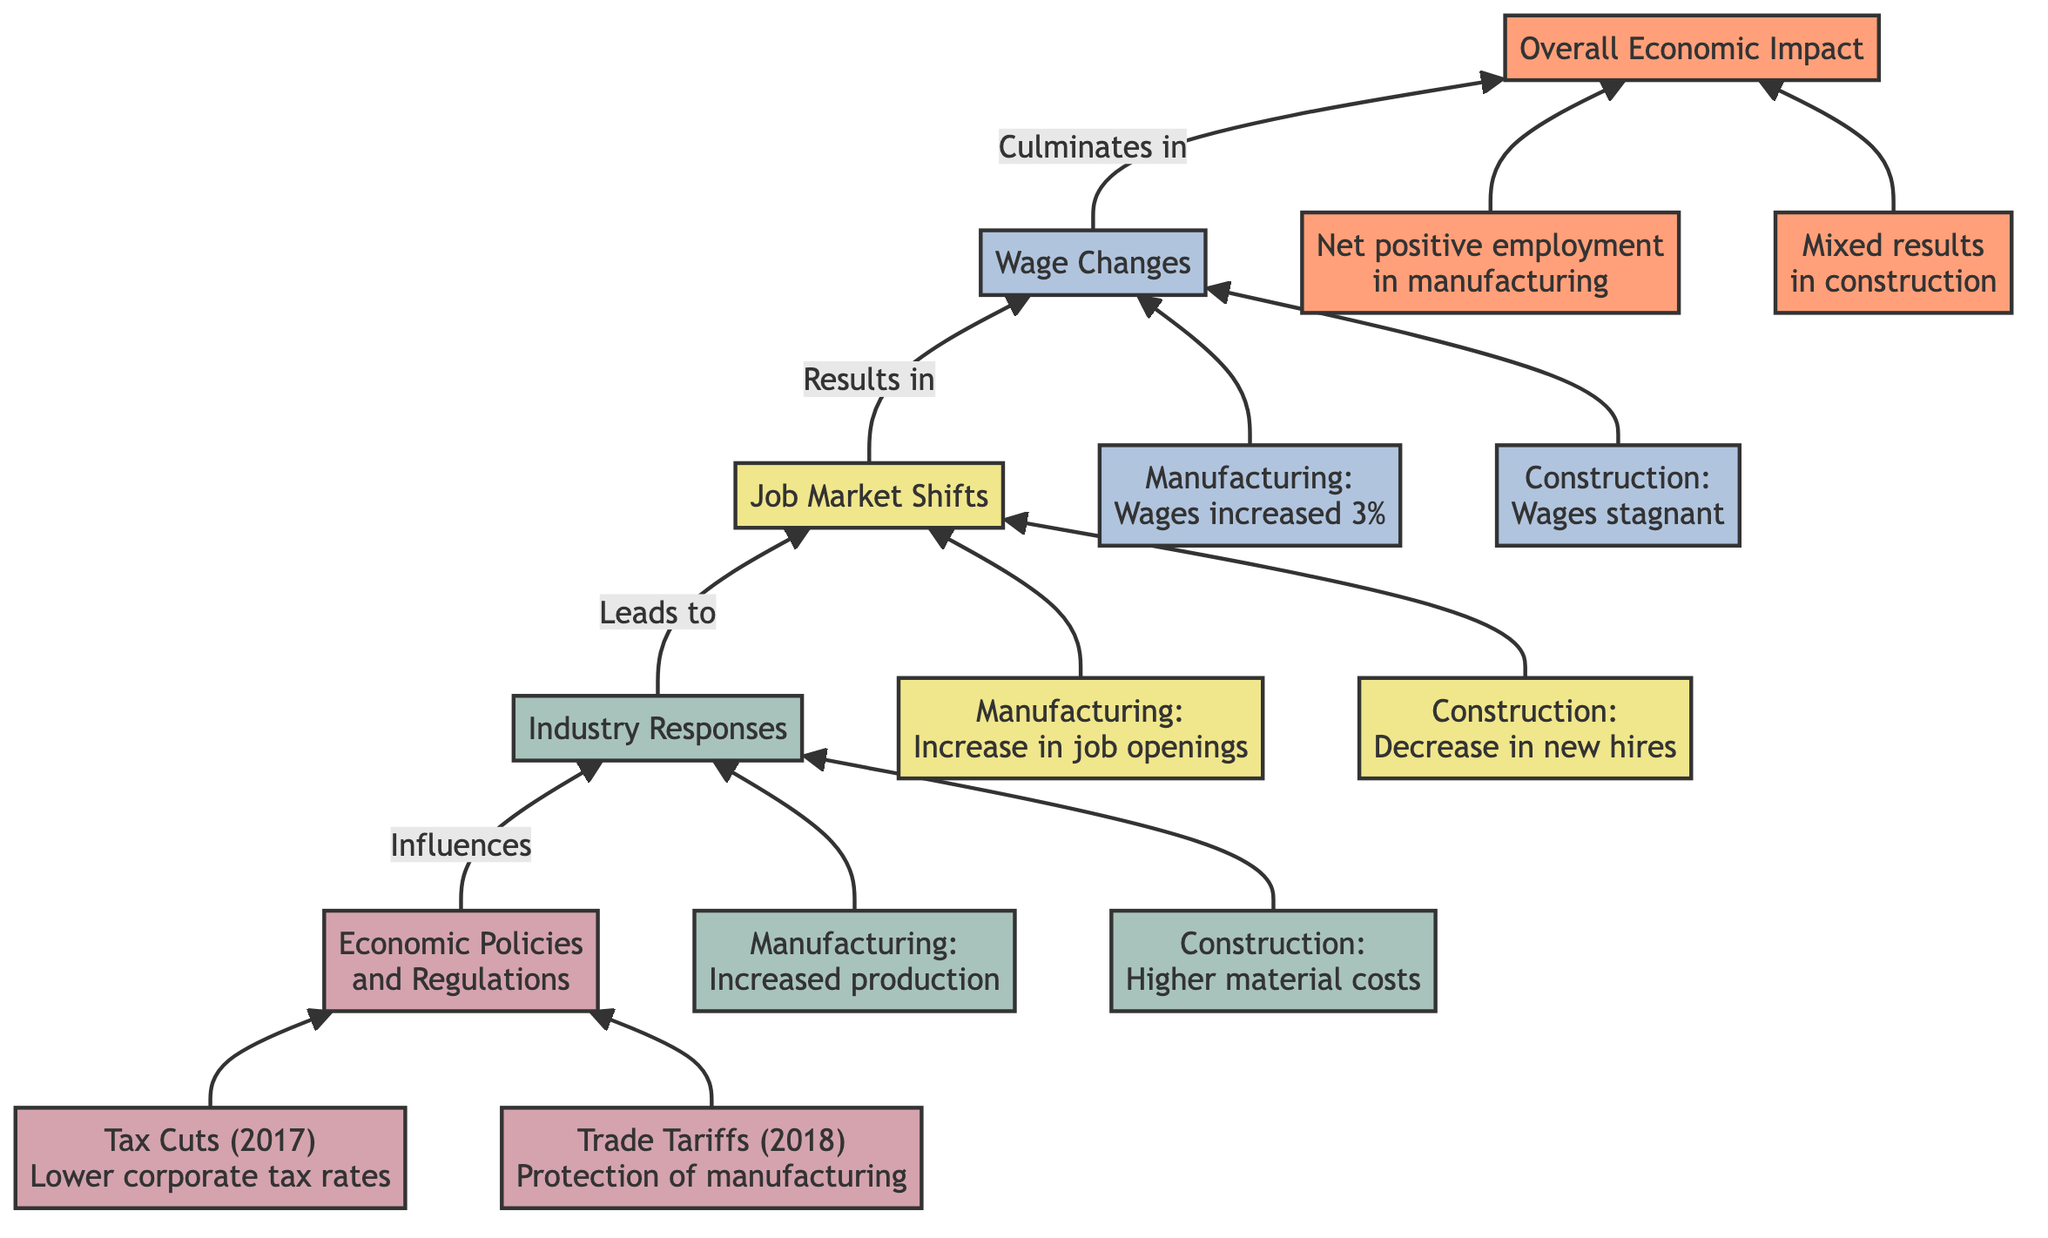What is the highest level in the diagram? The highest level in the diagram is "Overall Economic Impact," as it is the topmost node representing the outcome of the other elements.
Answer: Overall Economic Impact How many economic policies are listed in level 1? There are two economic policies mentioned: the "Tax Cuts and Jobs Act" and "Trade Tariffs on Steel and Aluminum."
Answer: 2 Which industry experienced a decrease in new hires? The "Construction" industry saw a decrease in new hires, indicated by the employment rate change noted in the diagram.
Answer: Construction What was the wage change in the manufacturing industry? The wage change in the manufacturing industry was an increase of 3%, as stated in the wage changes section of the diagram.
Answer: Wages increased by 3% What is the outcome for male-dominated sectors in manufacturing? The outcome is "Net positive employment in manufacturing," reflecting the favorable policies impacting that sector.
Answer: Net positive employment in manufacturing Which level includes details about job market shifts? Level 3 includes details about job market shifts, as indicated by the title "Job Market Shifts" for that particular node.
Answer: Job Market Shifts What was the impact of the Trade Tariffs on the construction industry? The impact was a "Slowdown in project commencements," resulting from the higher material costs associated with the tariffs.
Answer: Slowdown in project commencements How did tax cuts affect manufacturing employment rates? Tax cuts resulted in an "Increase in job openings" for the manufacturing sector, reflecting the positive impact of the policy.
Answer: Increase in job openings What is the connection between economic policies and industry responses? Economic policies influence industry responses, leading to specific outcomes in the job market and wages represented by the flow from level 1 to level 2.
Answer: Influences 